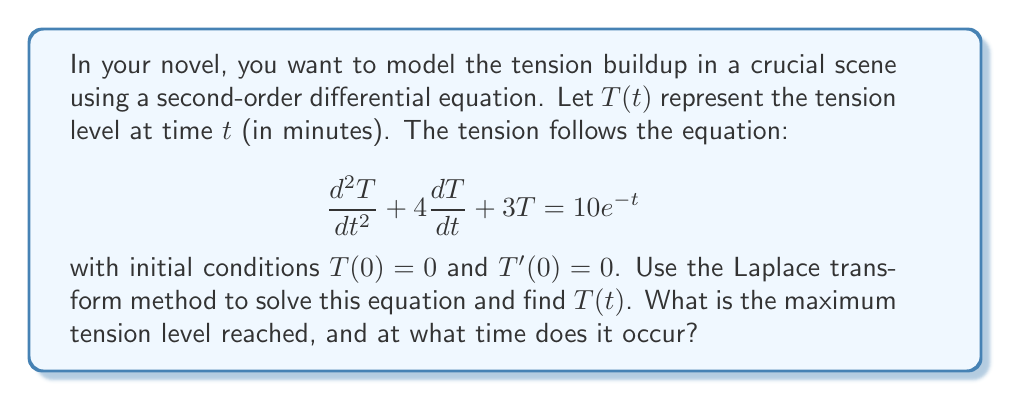Teach me how to tackle this problem. Let's solve this step-by-step using the Laplace transform method:

1) Take the Laplace transform of both sides of the equation:
   $$\mathcal{L}\{T''(t) + 4T'(t) + 3T(t)\} = \mathcal{L}\{10e^{-t}\}$$

2) Using Laplace transform properties:
   $$(s^2\mathcal{L}\{T(t)\} - sT(0) - T'(0)) + 4(s\mathcal{L}\{T(t)\} - T(0)) + 3\mathcal{L}\{T(t)\} = \frac{10}{s+1}$$

3) Substituting the initial conditions $T(0) = 0$ and $T'(0) = 0$:
   $$s^2\mathcal{L}\{T(t)\} + 4s\mathcal{L}\{T(t)\} + 3\mathcal{L}\{T(t)\} = \frac{10}{s+1}$$

4) Let $\mathcal{L}\{T(t)\} = X(s)$. Then:
   $$X(s)(s^2 + 4s + 3) = \frac{10}{s+1}$$

5) Solve for $X(s)$:
   $$X(s) = \frac{10}{(s+1)(s^2 + 4s + 3)} = \frac{10}{(s+1)(s+1)(s+3)}$$

6) Perform partial fraction decomposition:
   $$X(s) = \frac{A}{s+1} + \frac{B}{s+1} + \frac{C}{s+3}$$

   Solving for A, B, and C:
   $$A = \frac{5}{2}, B = -\frac{5}{2}, C = \frac{5}{2}$$

7) Therefore:
   $$X(s) = \frac{5/2}{s+1} - \frac{5/2}{(s+1)^2} + \frac{5/2}{s+3}$$

8) Take the inverse Laplace transform:
   $$T(t) = \frac{5}{2}e^{-t} - \frac{5}{2}te^{-t} + \frac{5}{2}e^{-3t}$$

9) To find the maximum tension, differentiate $T(t)$ and set it to zero:
   $$T'(t) = -\frac{5}{2}e^{-t} + \frac{5}{2}e^{-t} - \frac{5}{2}te^{-t} - \frac{15}{2}e^{-3t} = 0$$

10) Solving this equation numerically (as it's transcendental) gives the time of maximum tension:
    $t_{max} \approx 0.7642$ minutes

11) The maximum tension is:
    $T(t_{max}) \approx 1.0986$
Answer: The tension function is $T(t) = \frac{5}{2}e^{-t} - \frac{5}{2}te^{-t} + \frac{5}{2}e^{-3t}$. The maximum tension level is approximately 1.0986, occurring at approximately 0.7642 minutes. 